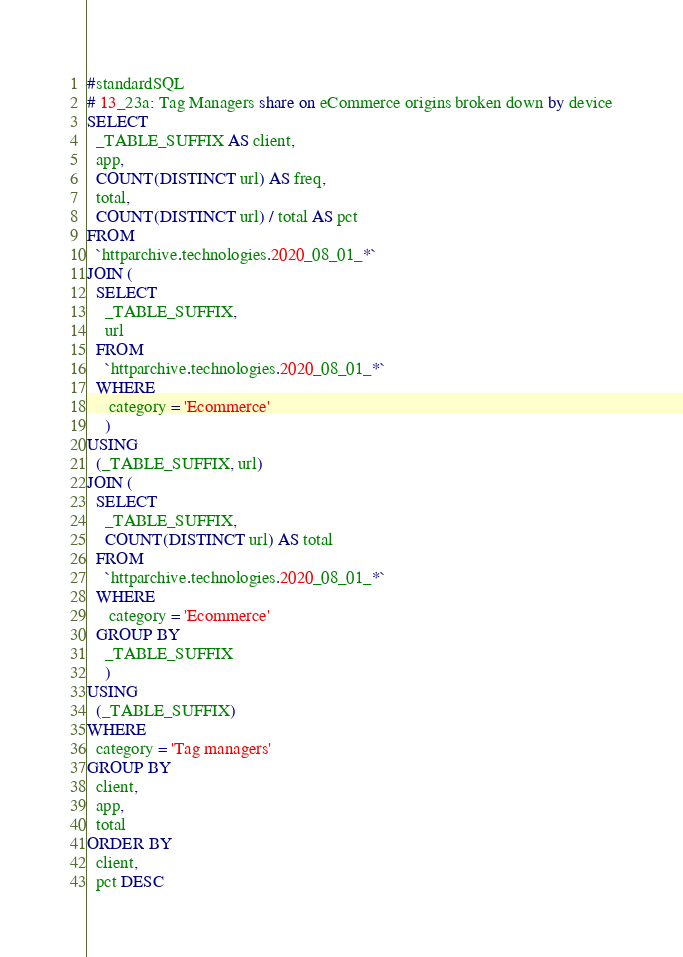<code> <loc_0><loc_0><loc_500><loc_500><_SQL_>#standardSQL
# 13_23a: Tag Managers share on eCommerce origins broken down by device
SELECT
  _TABLE_SUFFIX AS client,
  app,
  COUNT(DISTINCT url) AS freq,
  total,
  COUNT(DISTINCT url) / total AS pct
FROM
  `httparchive.technologies.2020_08_01_*`
JOIN (
  SELECT
    _TABLE_SUFFIX,
    url
  FROM
    `httparchive.technologies.2020_08_01_*`
  WHERE
     category = 'Ecommerce'
    )
USING
  (_TABLE_SUFFIX, url)
JOIN (
  SELECT
    _TABLE_SUFFIX,
    COUNT(DISTINCT url) AS total
  FROM
    `httparchive.technologies.2020_08_01_*`
  WHERE
     category = 'Ecommerce'
  GROUP BY
    _TABLE_SUFFIX
    )
USING
  (_TABLE_SUFFIX)
WHERE
  category = 'Tag managers'
GROUP BY
  client,
  app,
  total
ORDER BY
  client,
  pct DESC
</code> 